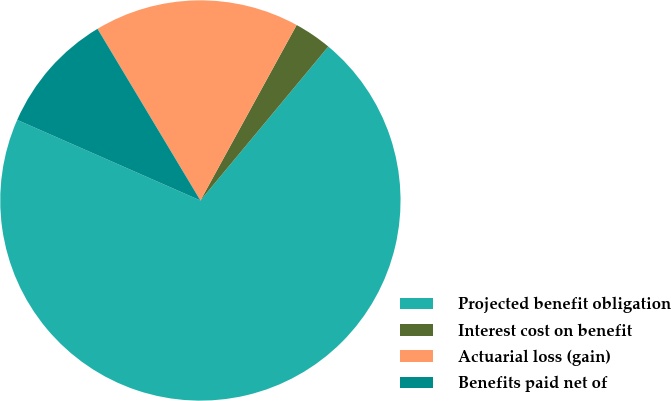Convert chart. <chart><loc_0><loc_0><loc_500><loc_500><pie_chart><fcel>Projected benefit obligation<fcel>Interest cost on benefit<fcel>Actuarial loss (gain)<fcel>Benefits paid net of<nl><fcel>70.56%<fcel>3.05%<fcel>16.58%<fcel>9.81%<nl></chart> 